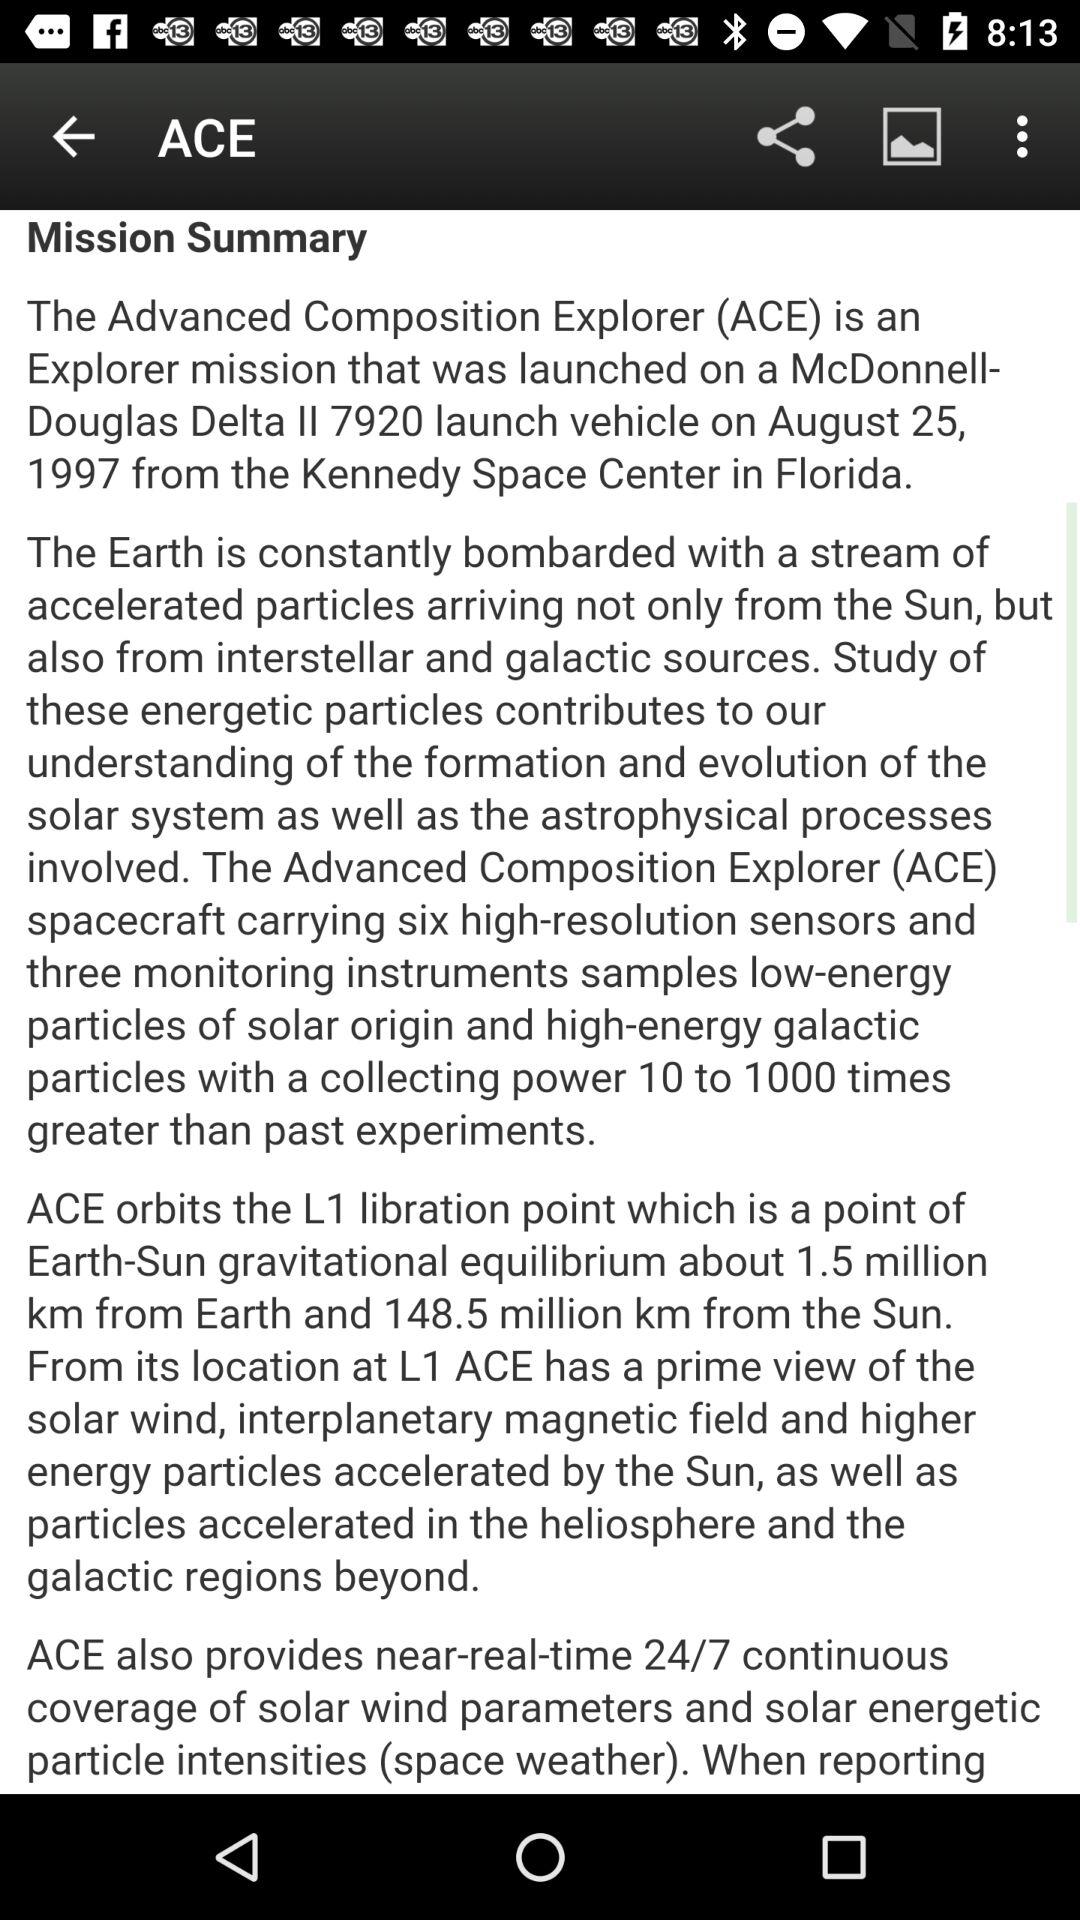How many instruments and sensors are there in the ACE spacecraft? The ACE spacecraft carries six high-resolution sensors and three monitoring instruments. 